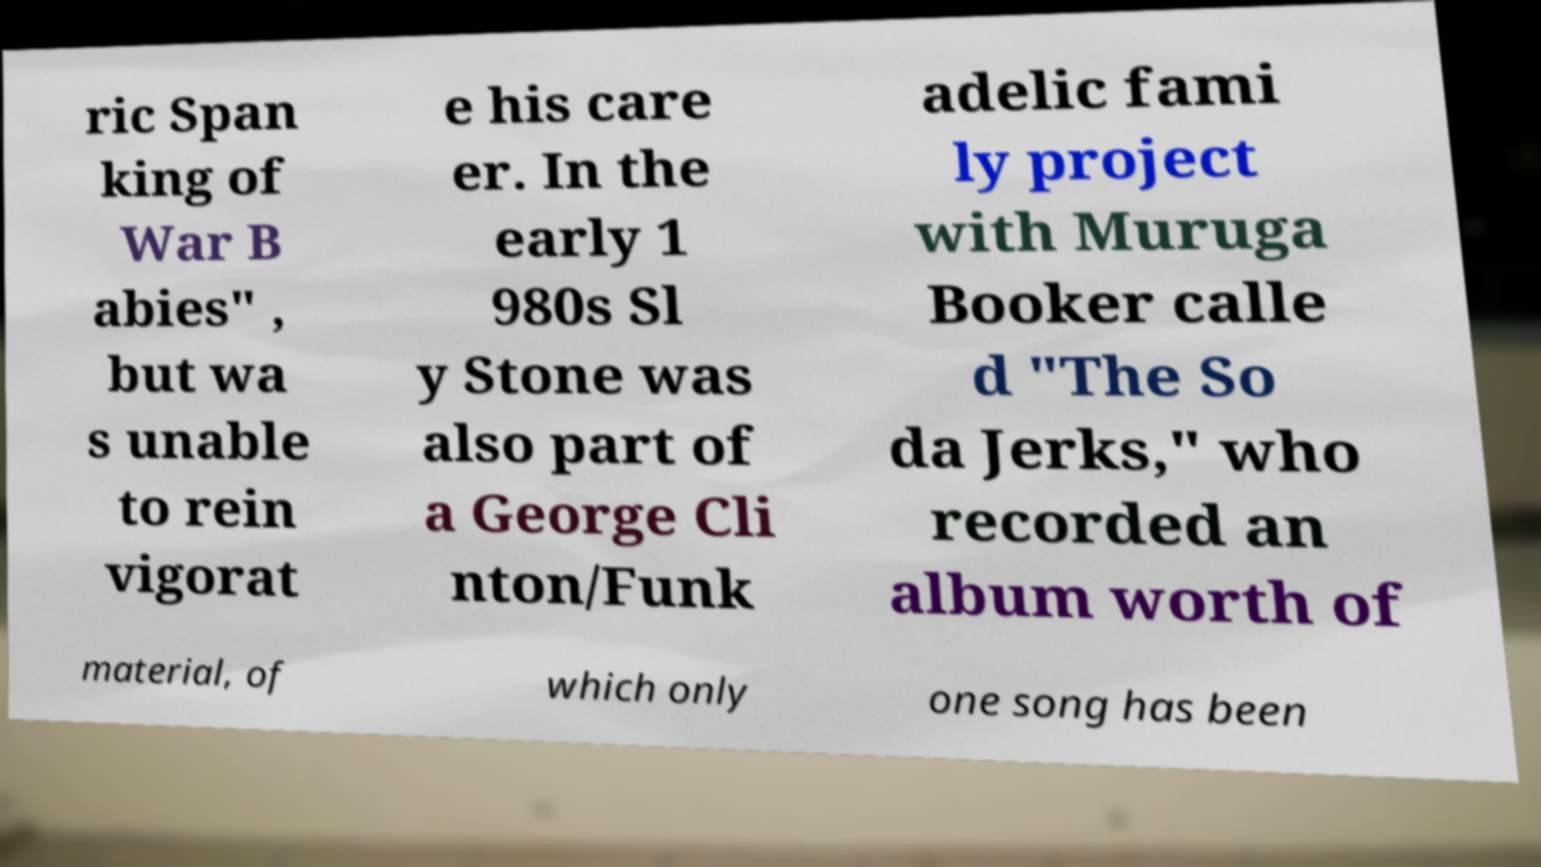I need the written content from this picture converted into text. Can you do that? ric Span king of War B abies" , but wa s unable to rein vigorat e his care er. In the early 1 980s Sl y Stone was also part of a George Cli nton/Funk adelic fami ly project with Muruga Booker calle d "The So da Jerks," who recorded an album worth of material, of which only one song has been 